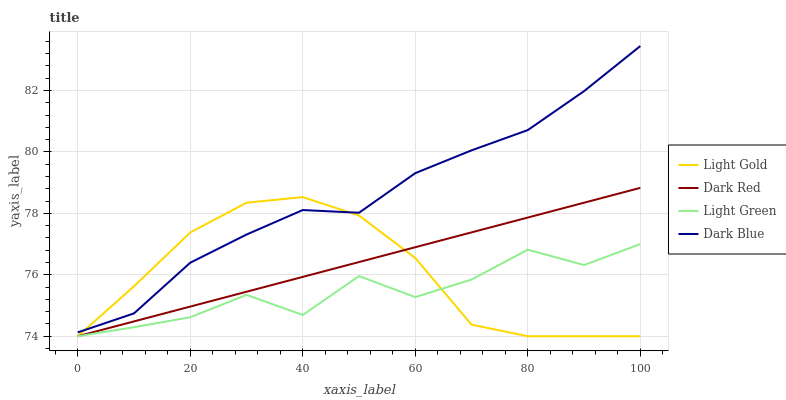Does Light Green have the minimum area under the curve?
Answer yes or no. Yes. Does Dark Blue have the maximum area under the curve?
Answer yes or no. Yes. Does Light Gold have the minimum area under the curve?
Answer yes or no. No. Does Light Gold have the maximum area under the curve?
Answer yes or no. No. Is Dark Red the smoothest?
Answer yes or no. Yes. Is Light Green the roughest?
Answer yes or no. Yes. Is Light Gold the smoothest?
Answer yes or no. No. Is Light Gold the roughest?
Answer yes or no. No. Does Dark Red have the lowest value?
Answer yes or no. Yes. Does Dark Blue have the lowest value?
Answer yes or no. No. Does Dark Blue have the highest value?
Answer yes or no. Yes. Does Light Gold have the highest value?
Answer yes or no. No. Is Light Green less than Dark Blue?
Answer yes or no. Yes. Is Dark Blue greater than Light Green?
Answer yes or no. Yes. Does Light Gold intersect Light Green?
Answer yes or no. Yes. Is Light Gold less than Light Green?
Answer yes or no. No. Is Light Gold greater than Light Green?
Answer yes or no. No. Does Light Green intersect Dark Blue?
Answer yes or no. No. 